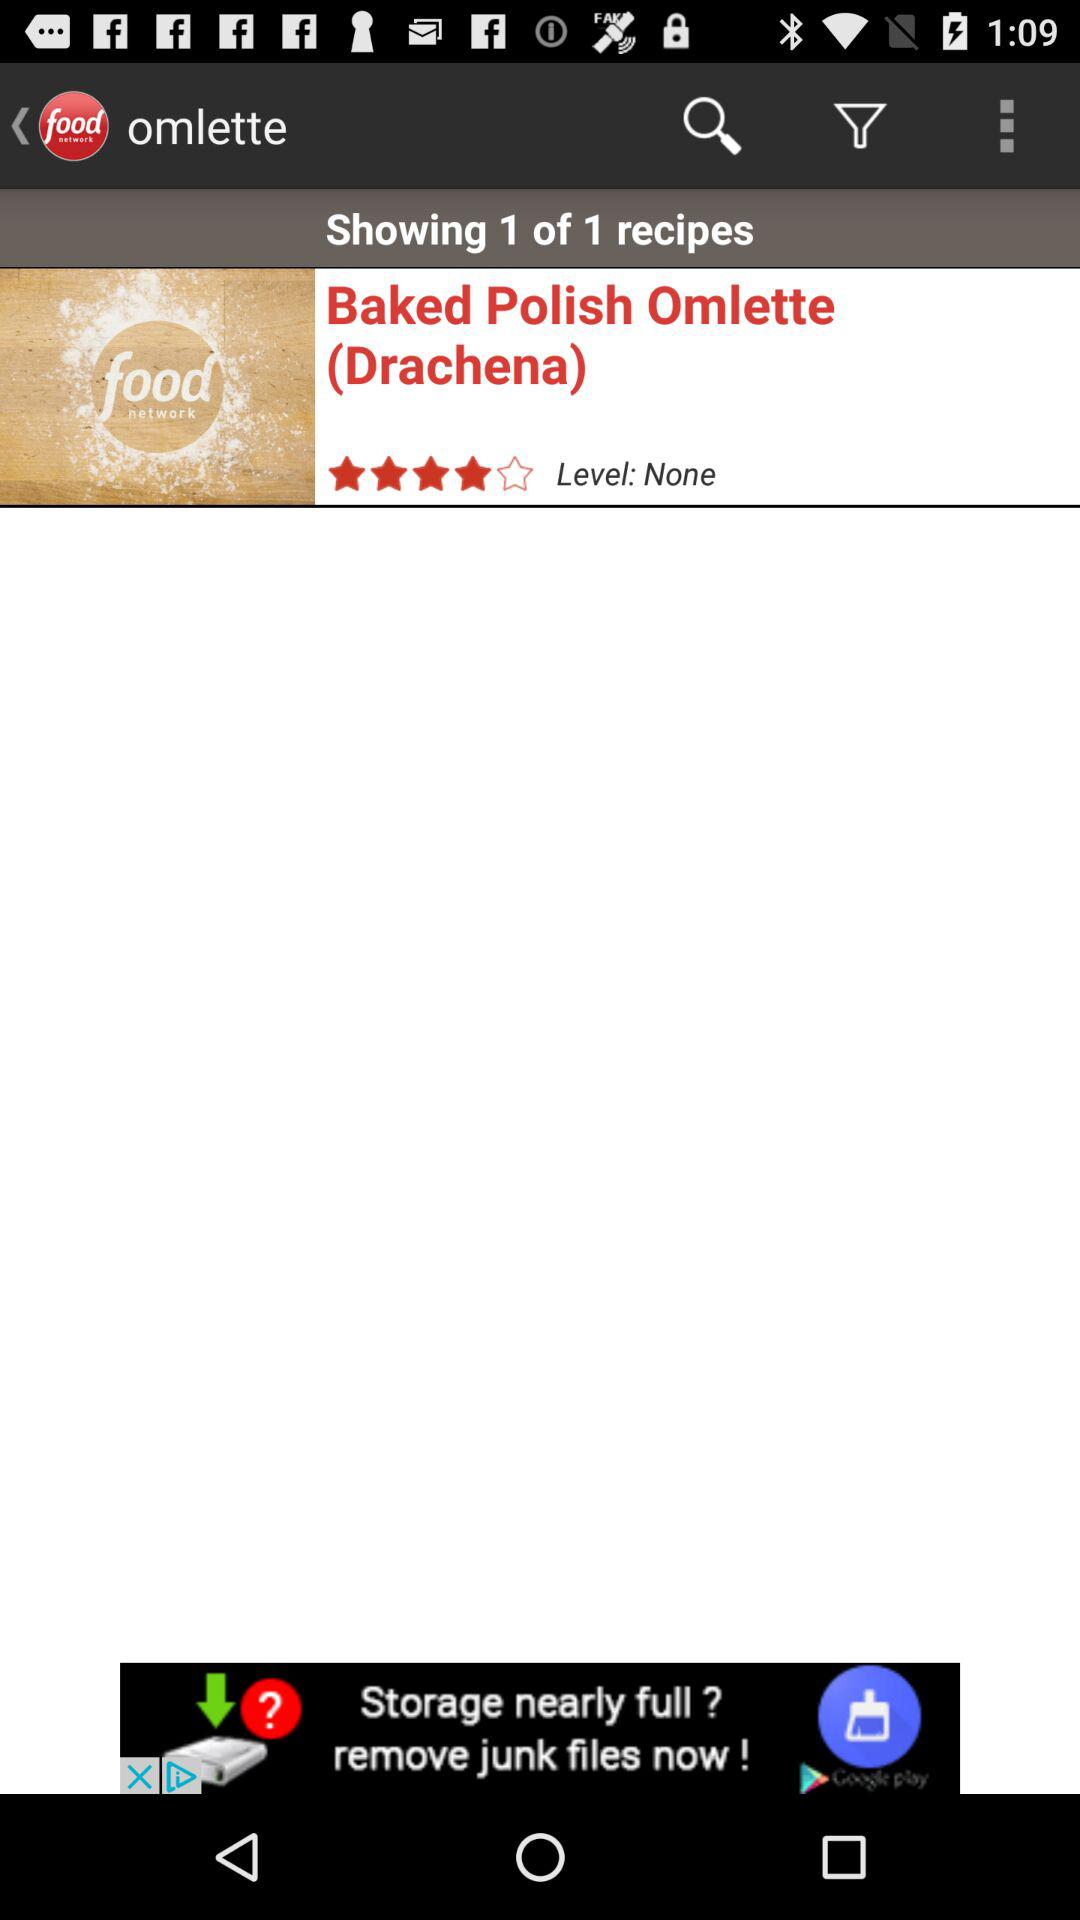How many recipes are shown? There is 1 recipe shown. 